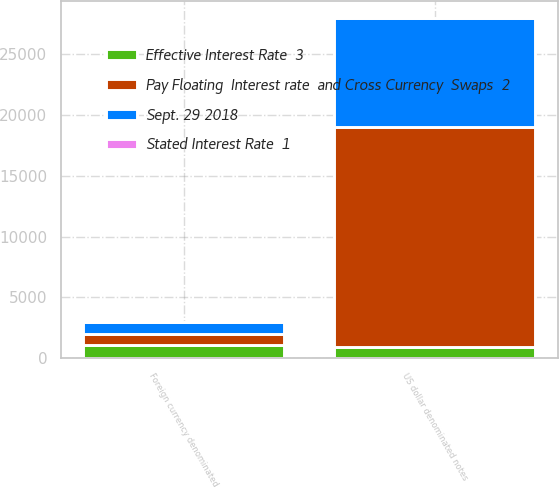Convert chart to OTSL. <chart><loc_0><loc_0><loc_500><loc_500><stacked_bar_chart><ecel><fcel>US dollar denominated notes<fcel>Foreign currency denominated<nl><fcel>Effective Interest Rate  3<fcel>955<fcel>1044<nl><fcel>Pay Floating  Interest rate  and Cross Currency  Swaps  2<fcel>18045<fcel>955<nl><fcel>Stated Interest Rate  1<fcel>3.97<fcel>3.18<nl><fcel>Sept. 29 2018<fcel>9000<fcel>940<nl></chart> 